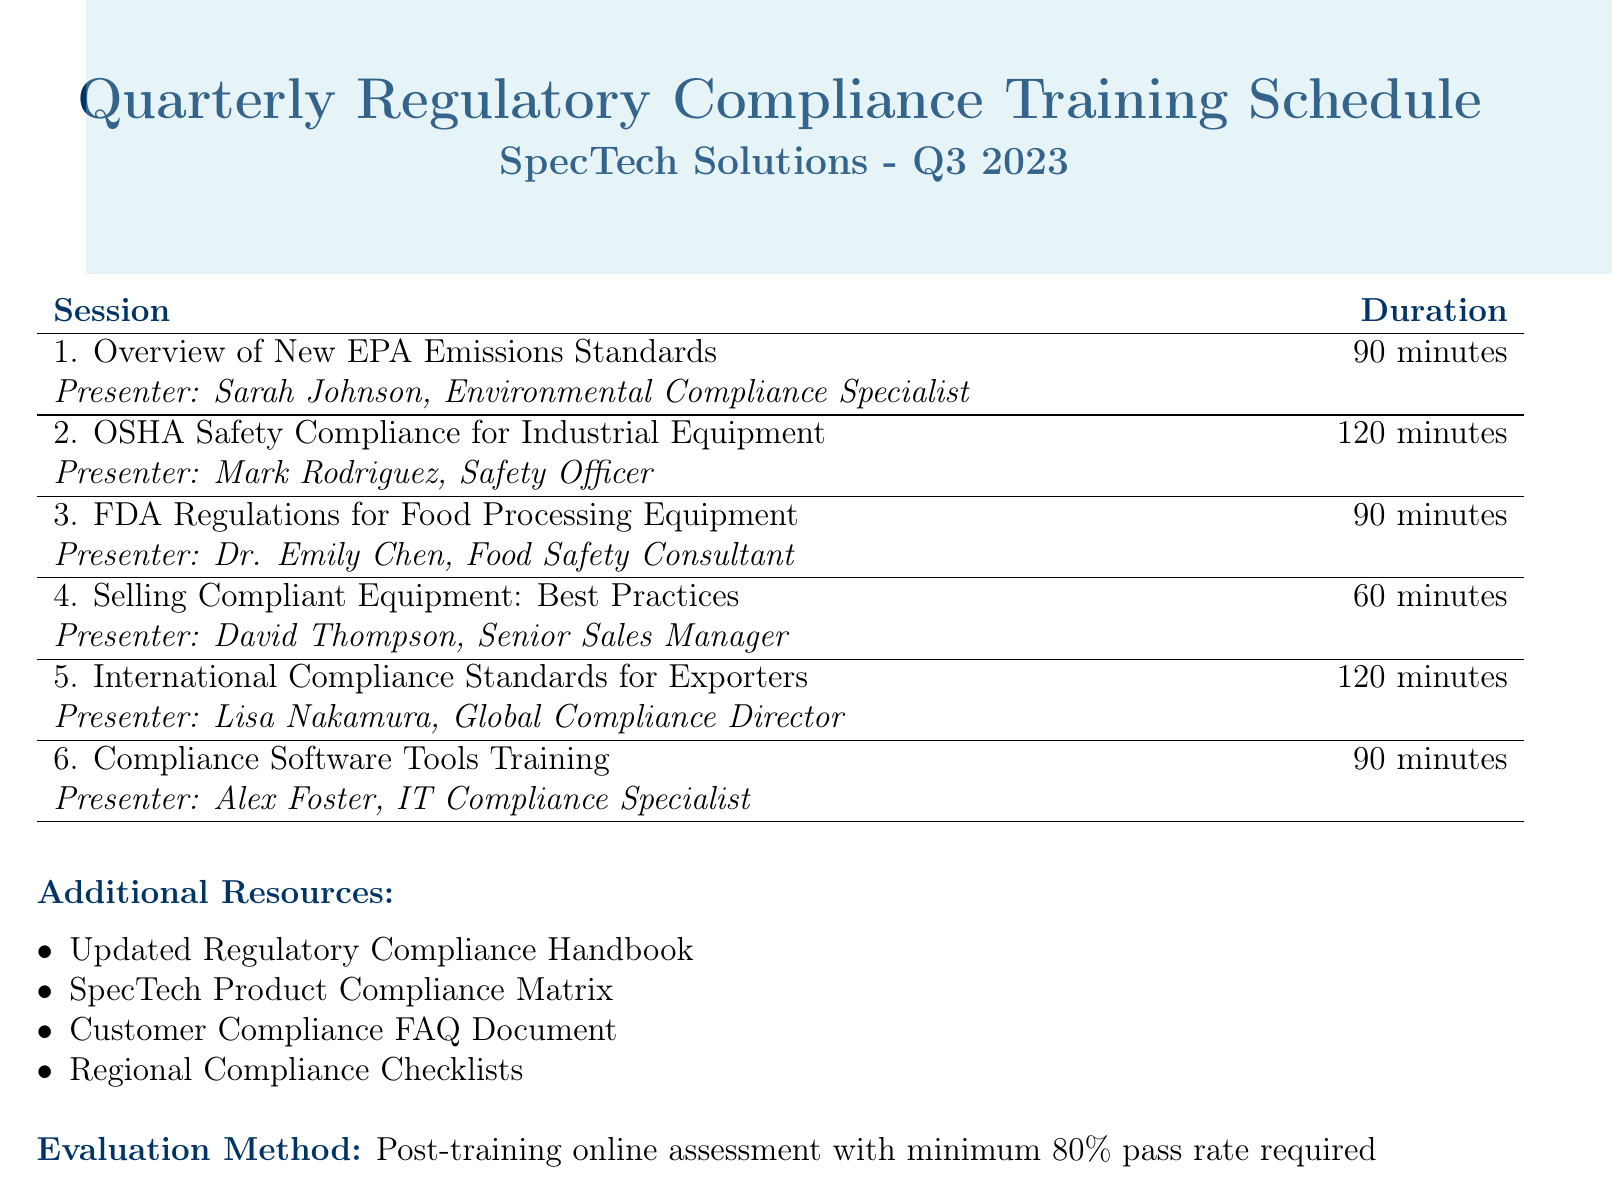what is the title of the agenda? The title of the agenda is specified at the beginning of the document.
Answer: Quarterly Regulatory Compliance Training Schedule for Sales Team who is the presenter for the session on FDA Regulations? The document lists presenters for each session, including their names and titles.
Answer: Dr. Emily Chen, Food Safety Consultant how long is the session on OSHA Safety Compliance? The duration of each session is mentioned next to its title in the document.
Answer: 120 minutes what is the evaluation method described in the agenda? The evaluation method is outlined at the end of the document, specifying how the training will be assessed.
Answer: Post-training online assessment with minimum 80% pass rate required what key topic is covered in the session on Selling Compliant Equipment? Each session lists its key topics, which provide insight into the content that will be covered.
Answer: Communicating compliance benefits to clients how many sessions are listed in the agenda? The total number of sessions can be counted in the session table in the document.
Answer: 6 sessions who presents the session on Compliance Software Tools Training? The document specifies the presenter of each session, which helps identify who is responsible for teaching.
Answer: Alex Foster, IT Compliance Specialist what is the duration of the session on International Compliance Standards? The duration for each session is explicitly mentioned in the document next to the session title.
Answer: 120 minutes 